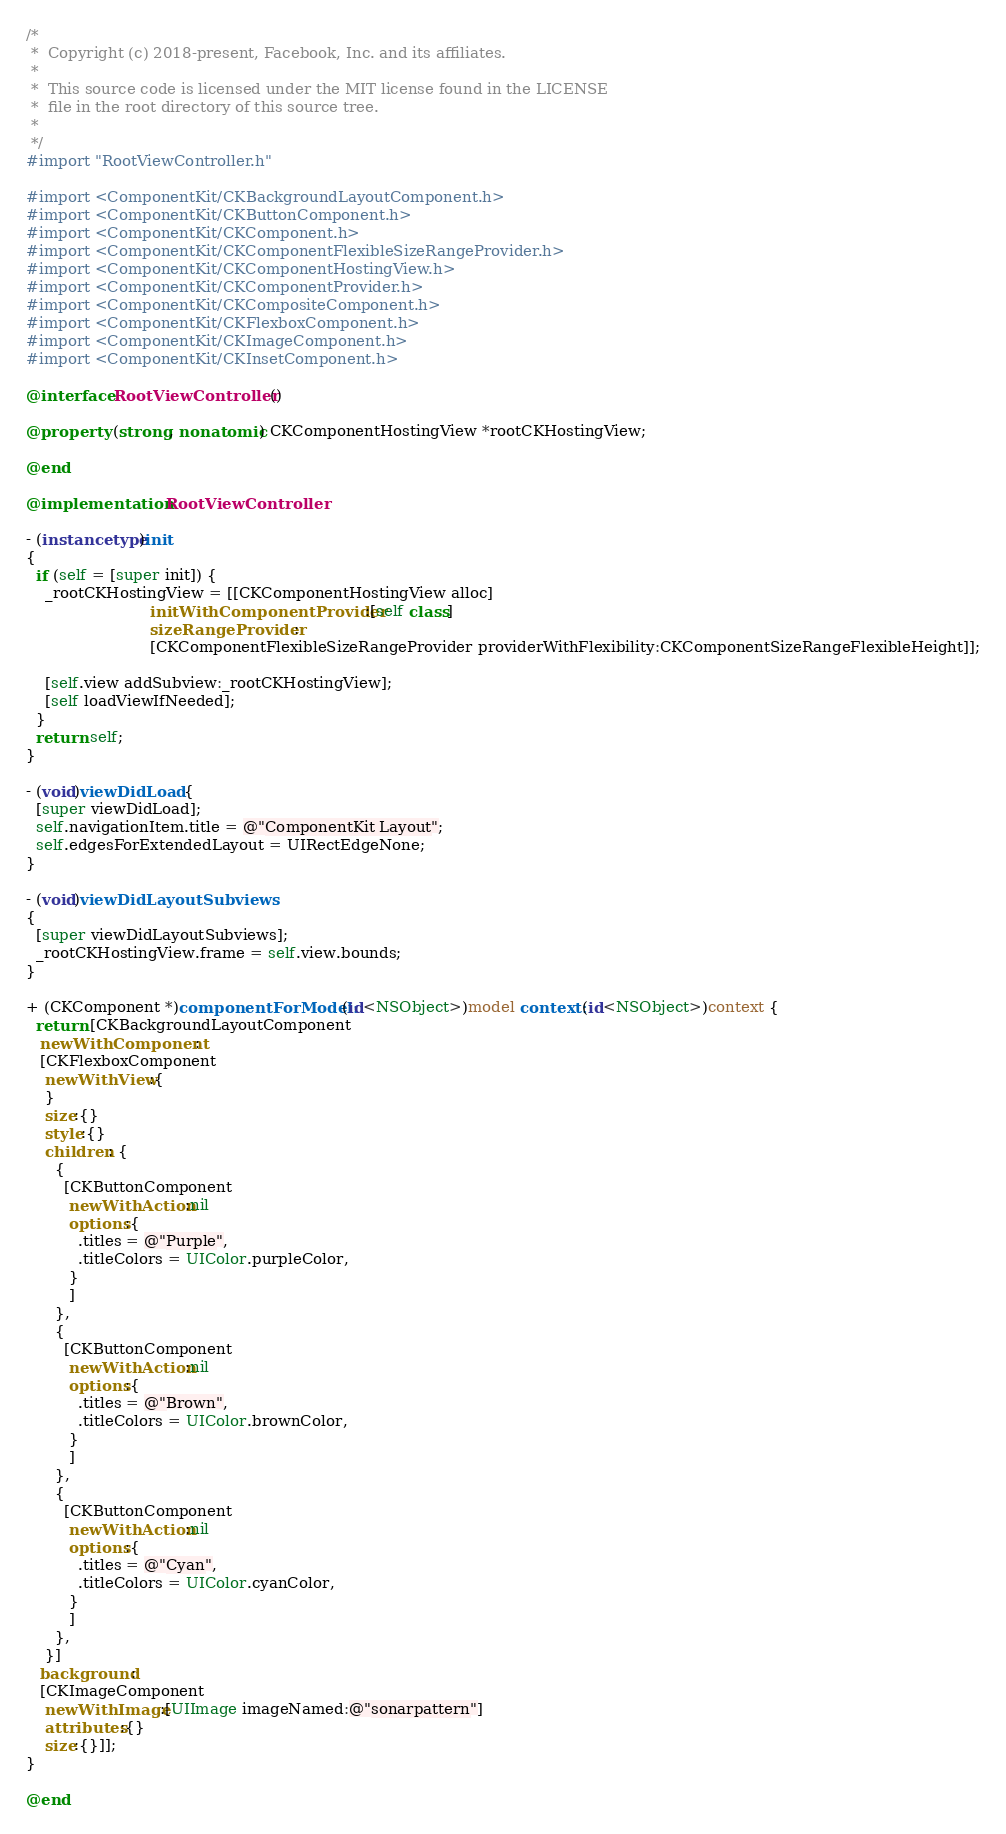<code> <loc_0><loc_0><loc_500><loc_500><_ObjectiveC_>/*
 *  Copyright (c) 2018-present, Facebook, Inc. and its affiliates.
 *
 *  This source code is licensed under the MIT license found in the LICENSE
 *  file in the root directory of this source tree.
 *
 */
#import "RootViewController.h"

#import <ComponentKit/CKBackgroundLayoutComponent.h>
#import <ComponentKit/CKButtonComponent.h>
#import <ComponentKit/CKComponent.h>
#import <ComponentKit/CKComponentFlexibleSizeRangeProvider.h>
#import <ComponentKit/CKComponentHostingView.h>
#import <ComponentKit/CKComponentProvider.h>
#import <ComponentKit/CKCompositeComponent.h>
#import <ComponentKit/CKFlexboxComponent.h>
#import <ComponentKit/CKImageComponent.h>
#import <ComponentKit/CKInsetComponent.h>

@interface RootViewController ()

@property (strong, nonatomic) CKComponentHostingView *rootCKHostingView;

@end

@implementation RootViewController

- (instancetype)init
{
  if (self = [super init]) {
    _rootCKHostingView = [[CKComponentHostingView alloc]
                          initWithComponentProvider:[self class]
                          sizeRangeProvider:
                          [CKComponentFlexibleSizeRangeProvider providerWithFlexibility:CKComponentSizeRangeFlexibleHeight]];

    [self.view addSubview:_rootCKHostingView];
    [self loadViewIfNeeded];
  }
  return self;
}

- (void)viewDidLoad {
  [super viewDidLoad];
  self.navigationItem.title = @"ComponentKit Layout";
  self.edgesForExtendedLayout = UIRectEdgeNone;
}

- (void)viewDidLayoutSubviews
{
  [super viewDidLayoutSubviews];
  _rootCKHostingView.frame = self.view.bounds;
}

+ (CKComponent *)componentForModel:(id<NSObject>)model context:(id<NSObject>)context {
  return [CKBackgroundLayoutComponent
   newWithComponent:
   [CKFlexboxComponent
    newWithView:{
    }
    size:{}
    style:{}
    children: {
      {
        [CKButtonComponent
         newWithAction:nil
         options:{
           .titles = @"Purple",
           .titleColors = UIColor.purpleColor,
         }
         ]
      },
      {
        [CKButtonComponent
         newWithAction:nil
         options:{
           .titles = @"Brown",
           .titleColors = UIColor.brownColor,
         }
         ]
      },
      {
        [CKButtonComponent
         newWithAction:nil
         options:{
           .titles = @"Cyan",
           .titleColors = UIColor.cyanColor,
         }
         ]
      },
    }]
   background:
   [CKImageComponent
    newWithImage:[UIImage imageNamed:@"sonarpattern"]
    attributes:{}
    size:{}]];
}

@end
</code> 